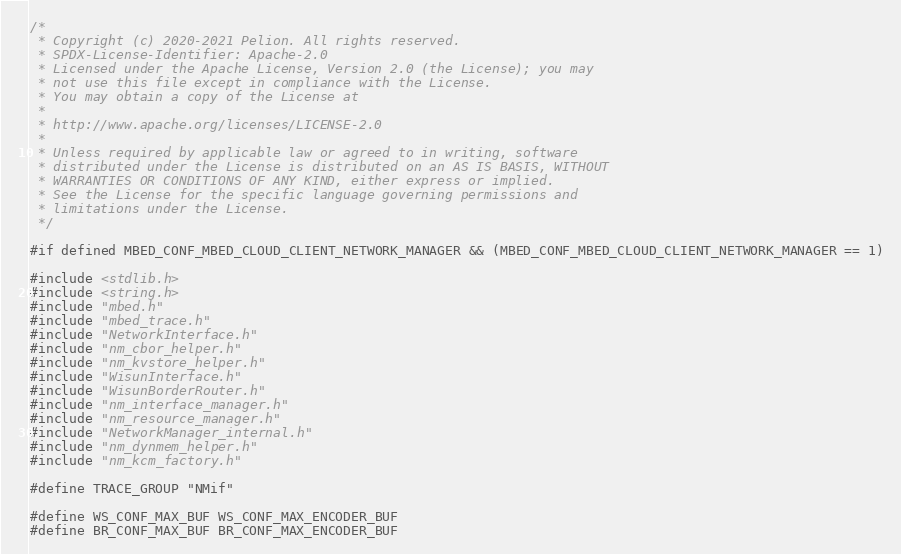Convert code to text. <code><loc_0><loc_0><loc_500><loc_500><_C++_>/*
 * Copyright (c) 2020-2021 Pelion. All rights reserved.
 * SPDX-License-Identifier: Apache-2.0
 * Licensed under the Apache License, Version 2.0 (the License); you may
 * not use this file except in compliance with the License.
 * You may obtain a copy of the License at
 *
 * http://www.apache.org/licenses/LICENSE-2.0
 *
 * Unless required by applicable law or agreed to in writing, software
 * distributed under the License is distributed on an AS IS BASIS, WITHOUT
 * WARRANTIES OR CONDITIONS OF ANY KIND, either express or implied.
 * See the License for the specific language governing permissions and
 * limitations under the License.
 */

#if defined MBED_CONF_MBED_CLOUD_CLIENT_NETWORK_MANAGER && (MBED_CONF_MBED_CLOUD_CLIENT_NETWORK_MANAGER == 1)

#include <stdlib.h>
#include <string.h>
#include "mbed.h"
#include "mbed_trace.h"
#include "NetworkInterface.h"
#include "nm_cbor_helper.h"
#include "nm_kvstore_helper.h"
#include "WisunInterface.h"
#include "WisunBorderRouter.h"
#include "nm_interface_manager.h"
#include "nm_resource_manager.h"
#include "NetworkManager_internal.h"
#include "nm_dynmem_helper.h"
#include "nm_kcm_factory.h"

#define TRACE_GROUP "NMif"

#define WS_CONF_MAX_BUF WS_CONF_MAX_ENCODER_BUF
#define BR_CONF_MAX_BUF BR_CONF_MAX_ENCODER_BUF</code> 